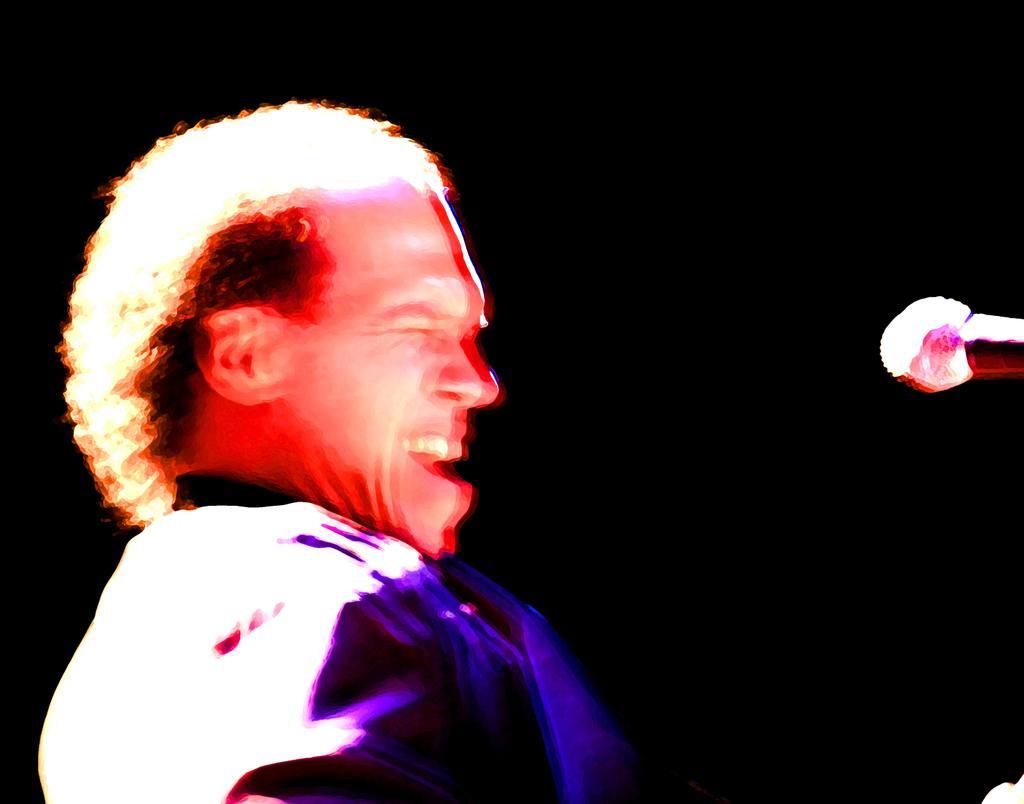Please provide a concise description of this image. In this image the background is dark. On the left side of the image there is a man and his face is a little blurred. On the right side of the image there is a mic. 